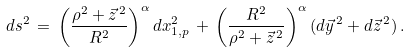Convert formula to latex. <formula><loc_0><loc_0><loc_500><loc_500>d s ^ { 2 } \, = \, \left ( \frac { \rho ^ { 2 } + \vec { z } ^ { \, 2 } } { R ^ { 2 } } \right ) ^ { \alpha } d x _ { 1 , p } ^ { 2 } \, + \, \left ( \frac { R ^ { 2 } } { \rho ^ { 2 } + \vec { z } ^ { \, 2 } } \right ) ^ { \alpha } ( d \vec { y } ^ { \, 2 } + d \vec { z } ^ { \, 2 } ) \, .</formula> 